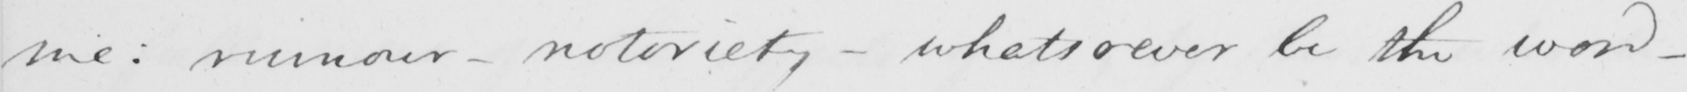What is written in this line of handwriting? me :  rumour  _  notoriety  _  whatsoever be the word  _ 